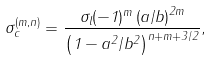Convert formula to latex. <formula><loc_0><loc_0><loc_500><loc_500>\sigma _ { c } ^ { ( m , n ) } = \frac { \sigma _ { l } ( - 1 ) ^ { m } \left ( a / b \right ) ^ { 2 m } } { \left ( 1 - a ^ { 2 } / b ^ { 2 } \right ) ^ { n + m + 3 / 2 } } ,</formula> 